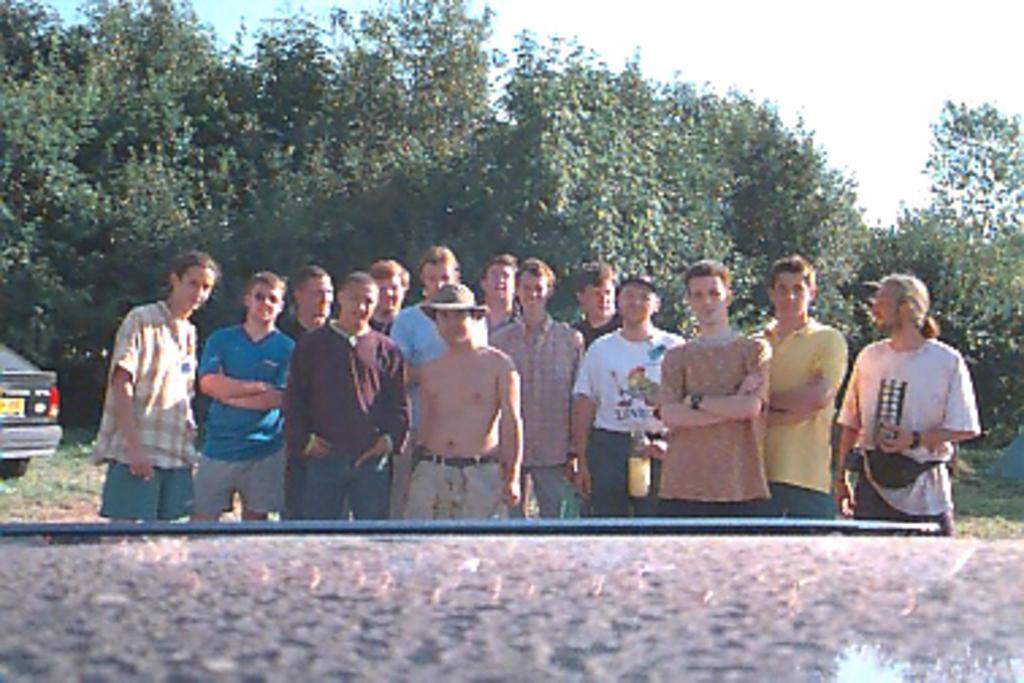Can you describe this image briefly? This picture is clicked outside. In the center we can see the group of persons standing on the ground and we can see a vehicle, green grass and trees. In the background we can see the sky. In the foreground we can see some other objects. 